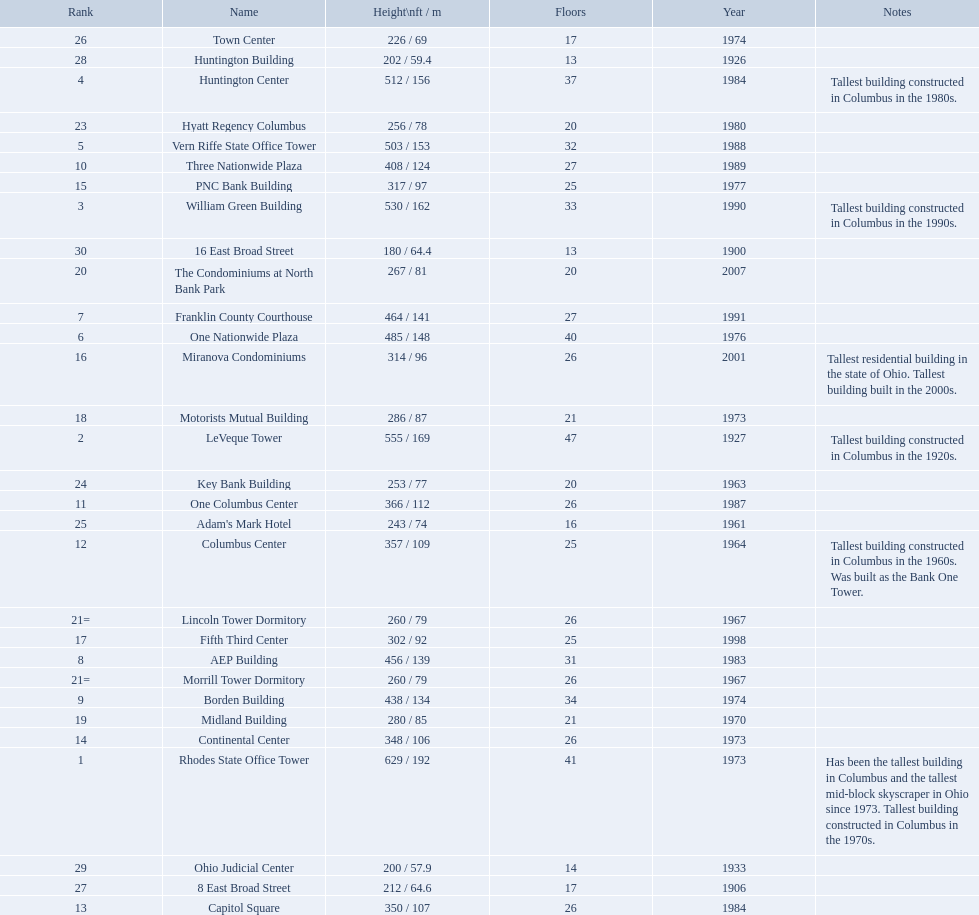Which of the tallest buildings in columbus, ohio were built in the 1980s? Huntington Center, Vern Riffe State Office Tower, AEP Building, Three Nationwide Plaza, One Columbus Center, Capitol Square, Hyatt Regency Columbus. Of these buildings, which have between 26 and 31 floors? AEP Building, Three Nationwide Plaza, One Columbus Center, Capitol Square. Of these buildings, which is the tallest? AEP Building. How tall is the aep building? 456 / 139. How tall is the one columbus center? 366 / 112. Of these two buildings, which is taller? AEP Building. 